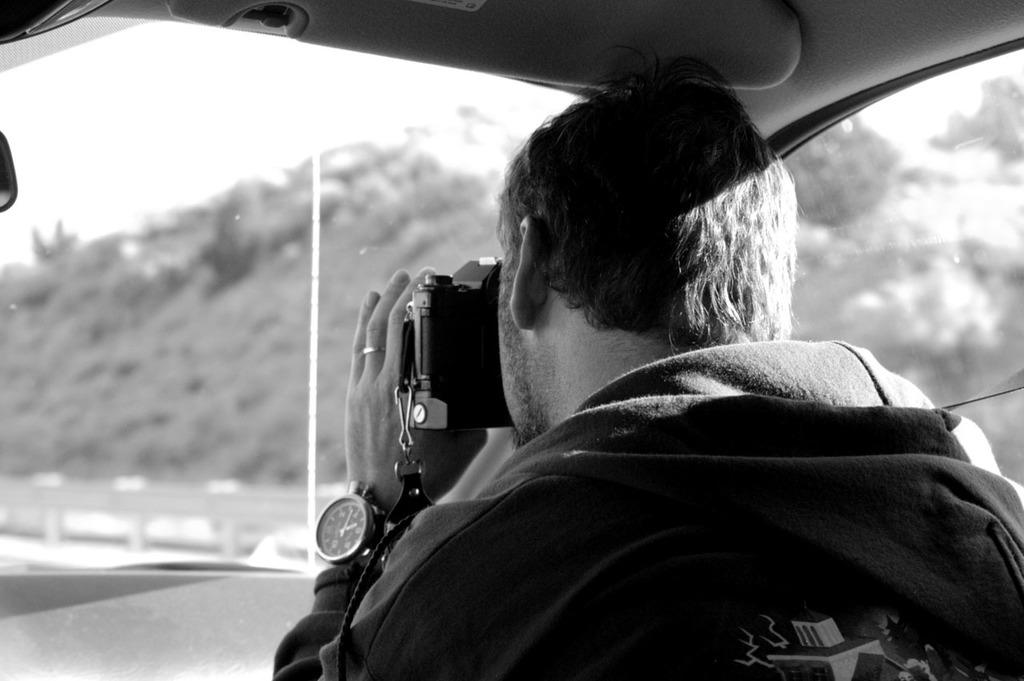Where was the image taken? The image is taken inside a car. Who is present in the image? There is a man sitting in the car. What is the man holding in the image? The man is holding a camera. What can be seen in the background through the window glass? Hills and the sky are visible in the background through the window glass. What type of garden can be seen through the window glass in the image? There is no garden visible through the window glass in the image; only hills and the sky are present. What part of the man's arm is visible in the image? The image does not show any part of the man's arm; it only shows him holding a camera. 